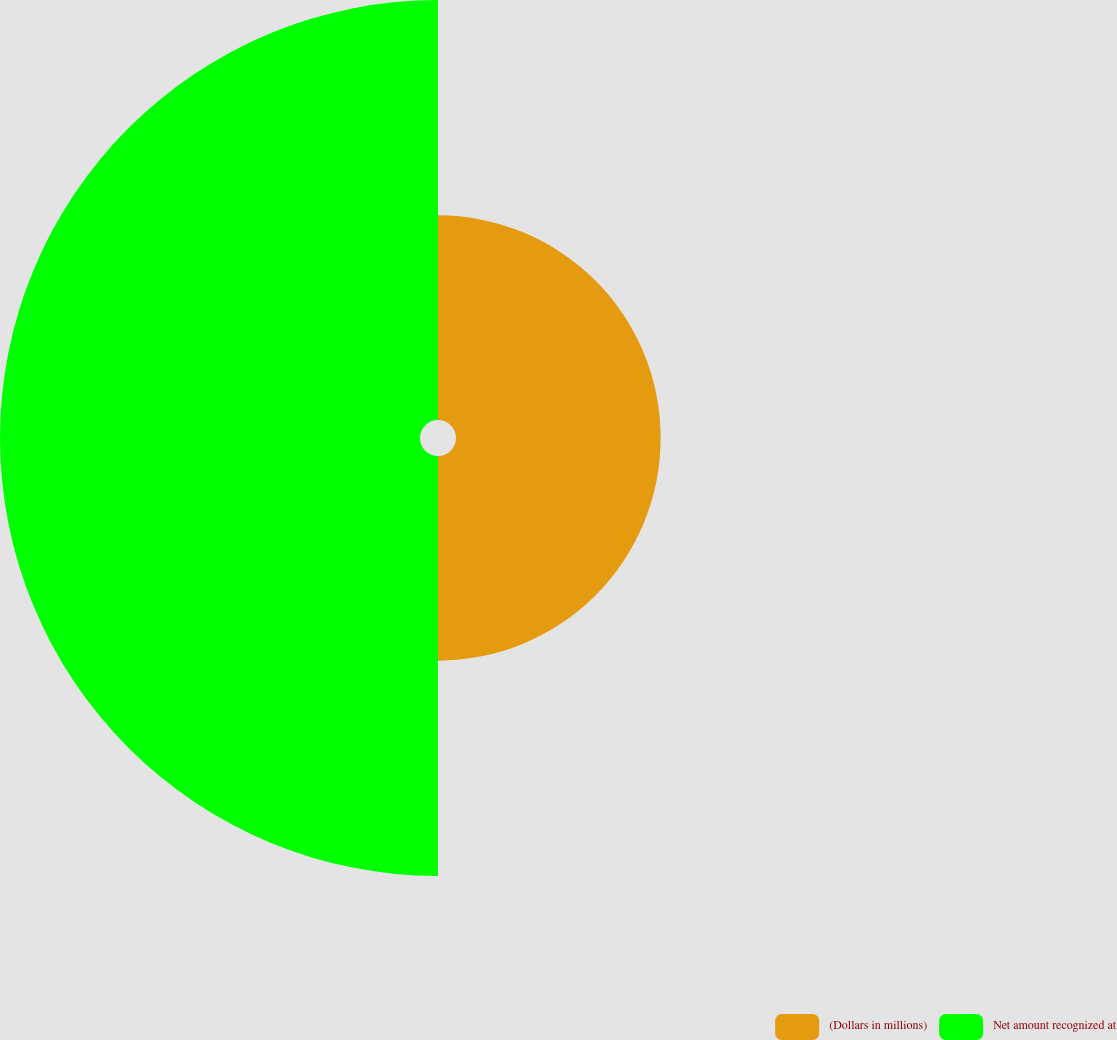Convert chart. <chart><loc_0><loc_0><loc_500><loc_500><pie_chart><fcel>(Dollars in millions)<fcel>Net amount recognized at<nl><fcel>32.76%<fcel>67.24%<nl></chart> 